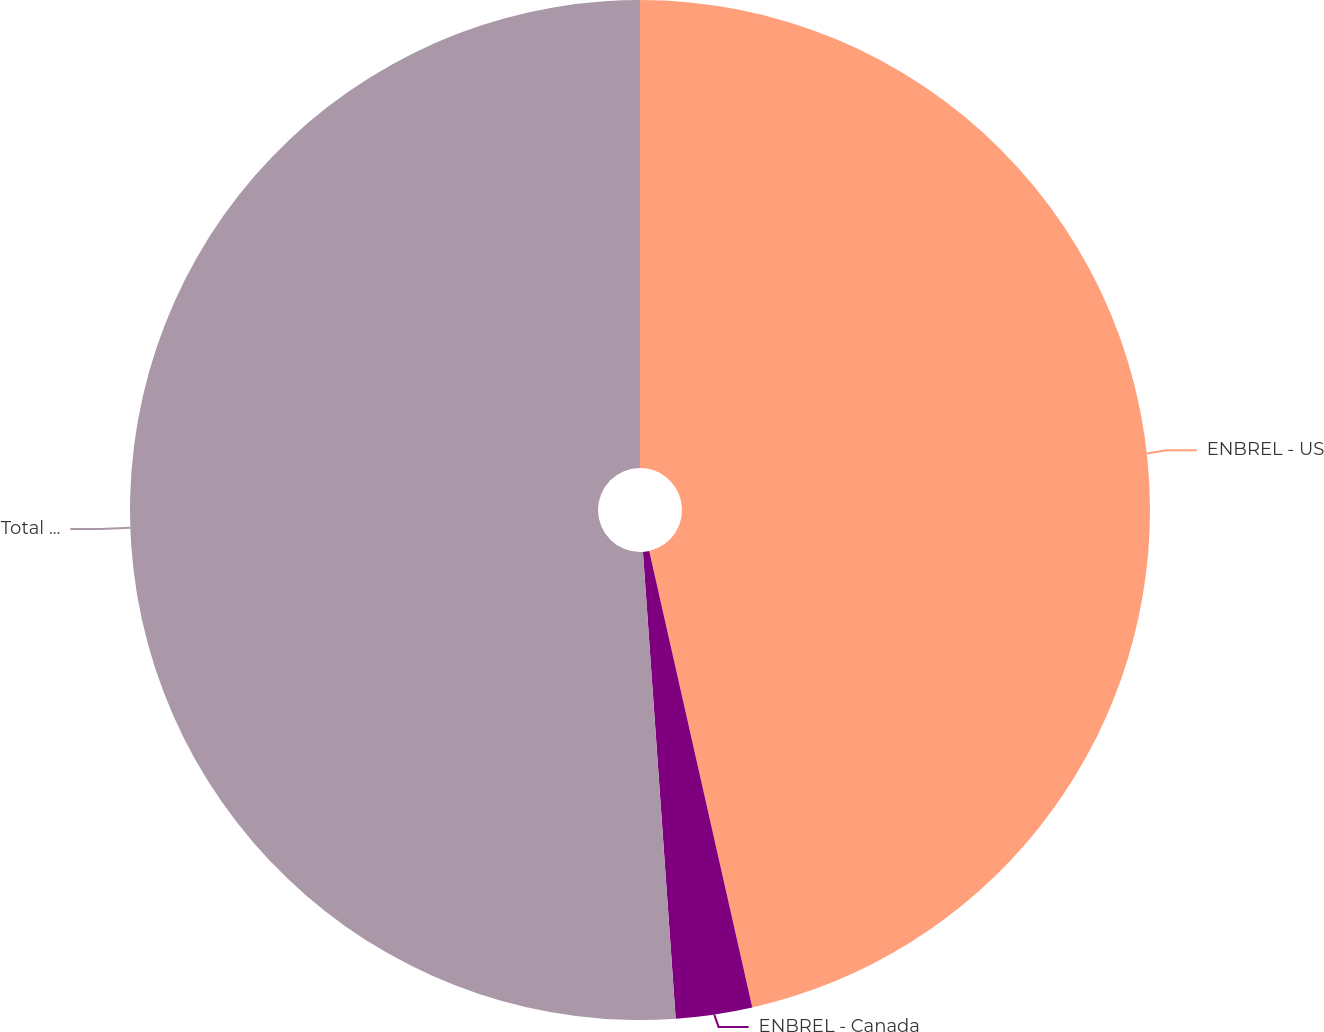Convert chart. <chart><loc_0><loc_0><loc_500><loc_500><pie_chart><fcel>ENBREL - US<fcel>ENBREL - Canada<fcel>Total ENBREL<nl><fcel>46.47%<fcel>2.42%<fcel>51.12%<nl></chart> 